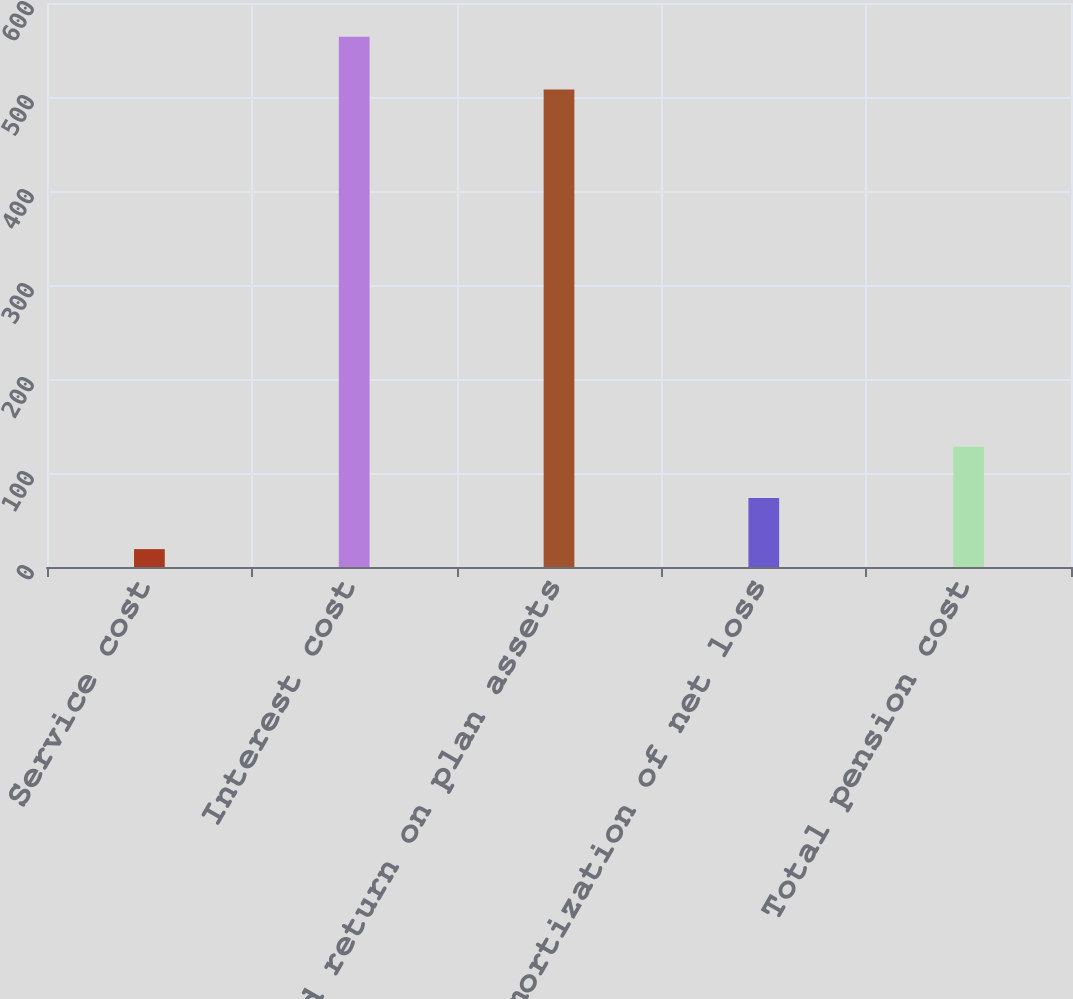Convert chart. <chart><loc_0><loc_0><loc_500><loc_500><bar_chart><fcel>Service cost<fcel>Interest cost<fcel>Expected return on plan assets<fcel>Amortization of net loss<fcel>Total pension cost<nl><fcel>19<fcel>564<fcel>508<fcel>73.5<fcel>128<nl></chart> 